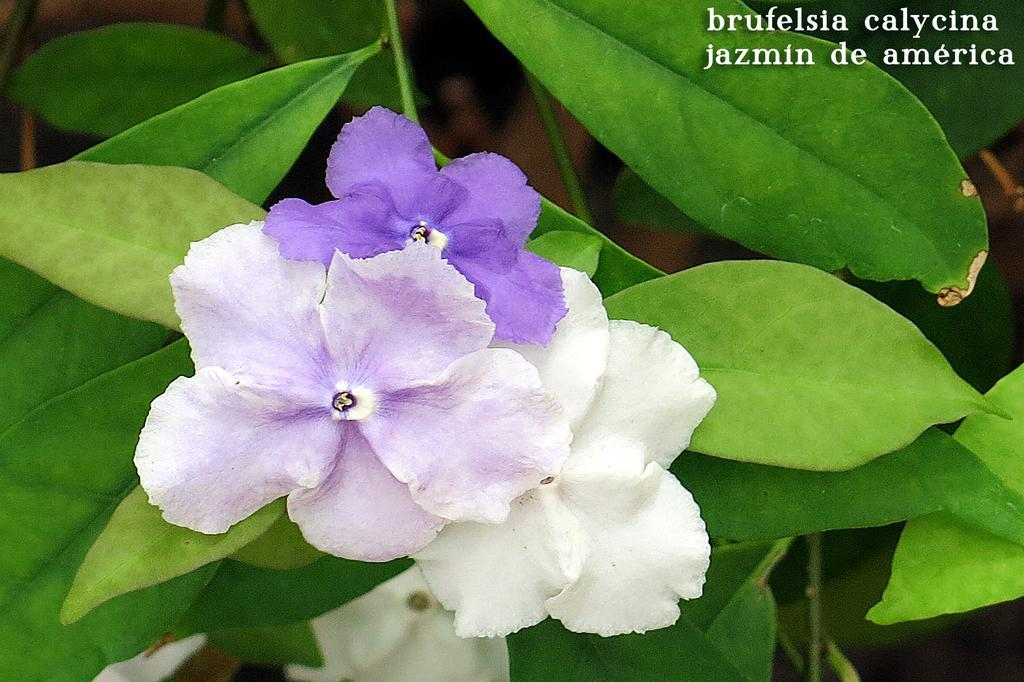What type of plant material is present in the image? There are green leaves in the image. How are the leaves attached to the plant? The leaves are on stems. What colors of flowers can be seen in the image? There are white and purple flowers in the image. Are there any words visible in the image? Yes, there are words visible in the image. How does the boy grip the body in the image? There is no boy or body present in the image; it features green leaves, stems, and flowers. 